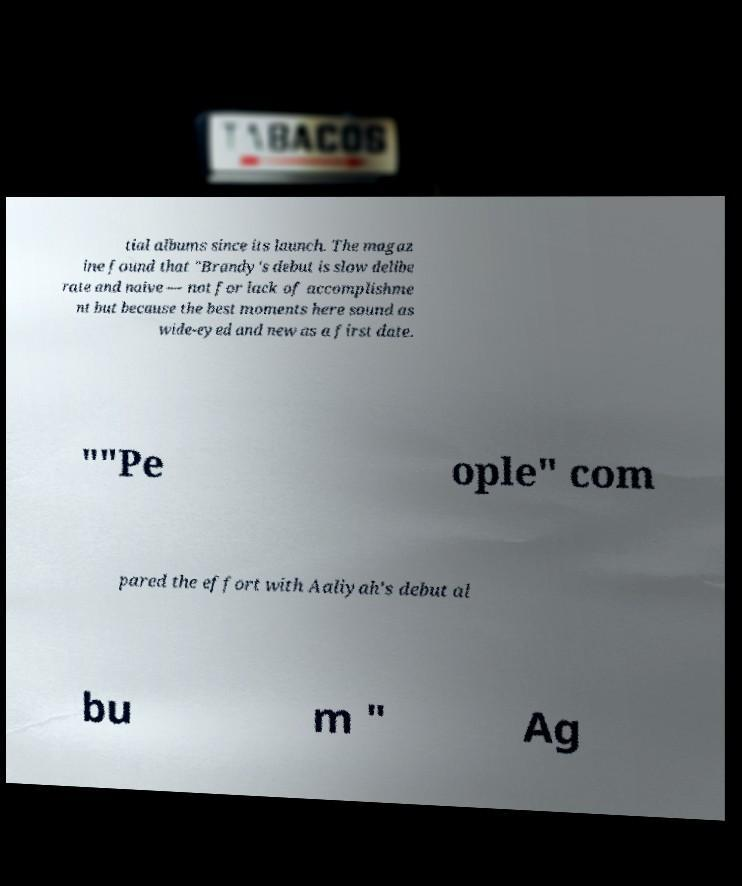There's text embedded in this image that I need extracted. Can you transcribe it verbatim? tial albums since its launch. The magaz ine found that "Brandy's debut is slow delibe rate and naive — not for lack of accomplishme nt but because the best moments here sound as wide-eyed and new as a first date. ""Pe ople" com pared the effort with Aaliyah's debut al bu m " Ag 